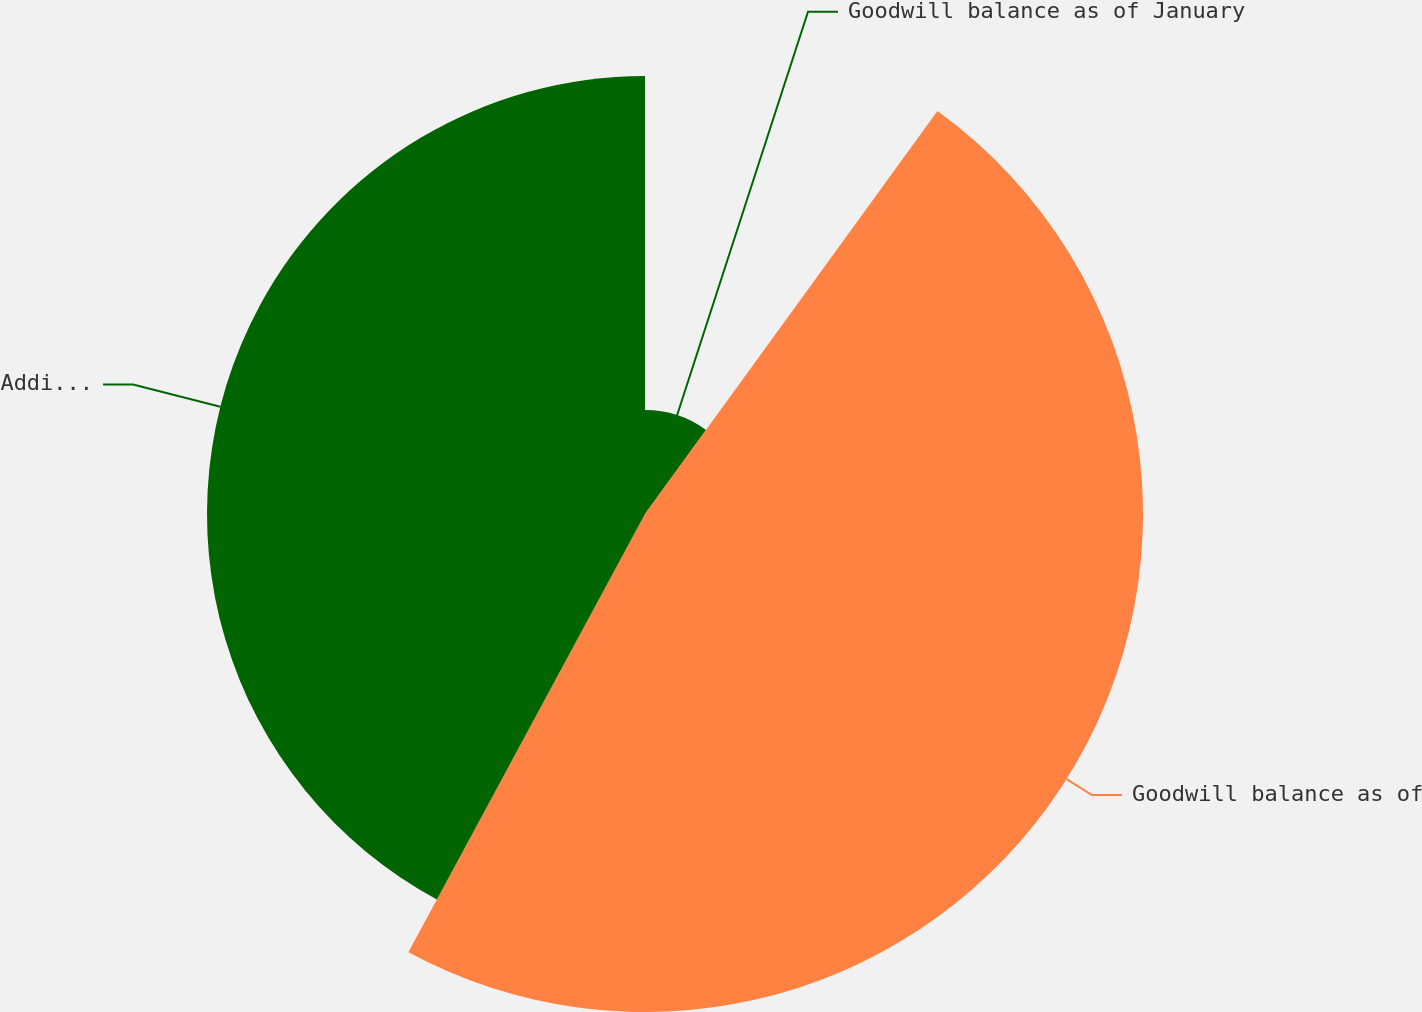Convert chart. <chart><loc_0><loc_0><loc_500><loc_500><pie_chart><fcel>Goodwill balance as of January<fcel>Goodwill balance as of<fcel>Additions<nl><fcel>9.99%<fcel>47.89%<fcel>42.12%<nl></chart> 